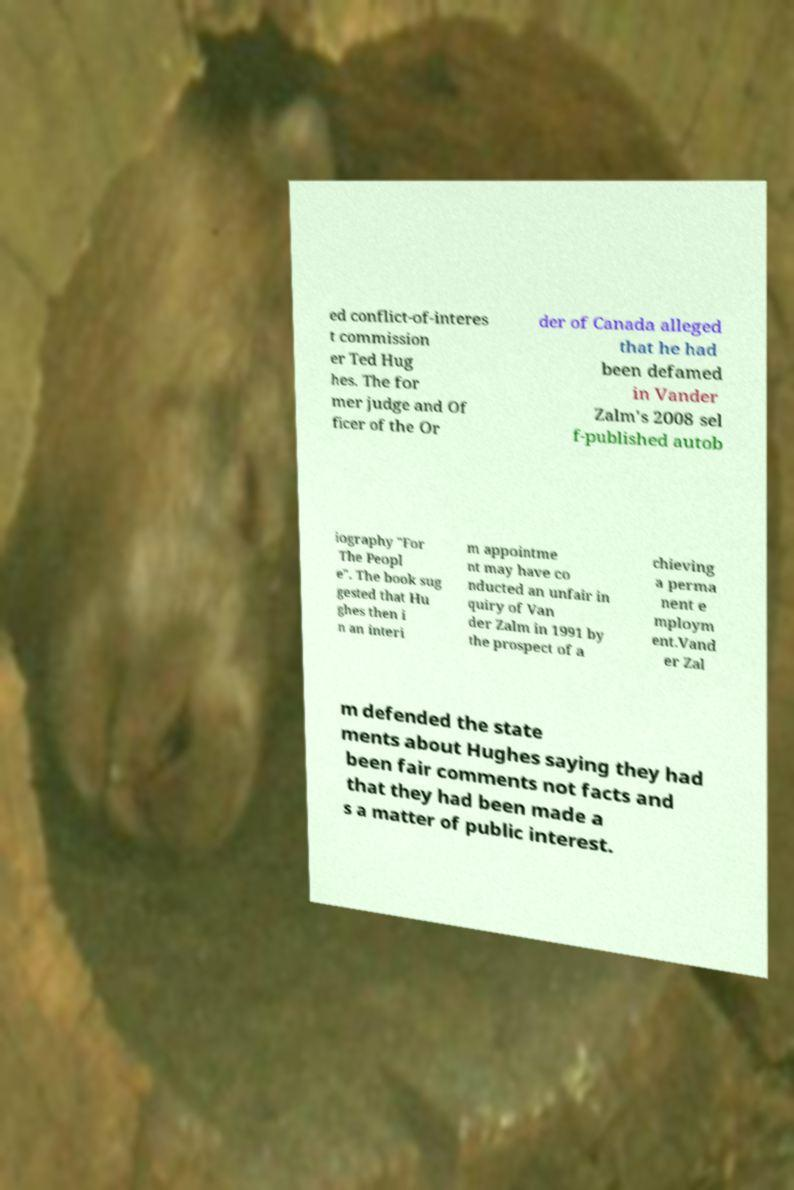For documentation purposes, I need the text within this image transcribed. Could you provide that? ed conflict-of-interes t commission er Ted Hug hes. The for mer judge and Of ficer of the Or der of Canada alleged that he had been defamed in Vander Zalm's 2008 sel f-published autob iography "For The Peopl e". The book sug gested that Hu ghes then i n an interi m appointme nt may have co nducted an unfair in quiry of Van der Zalm in 1991 by the prospect of a chieving a perma nent e mploym ent.Vand er Zal m defended the state ments about Hughes saying they had been fair comments not facts and that they had been made a s a matter of public interest. 